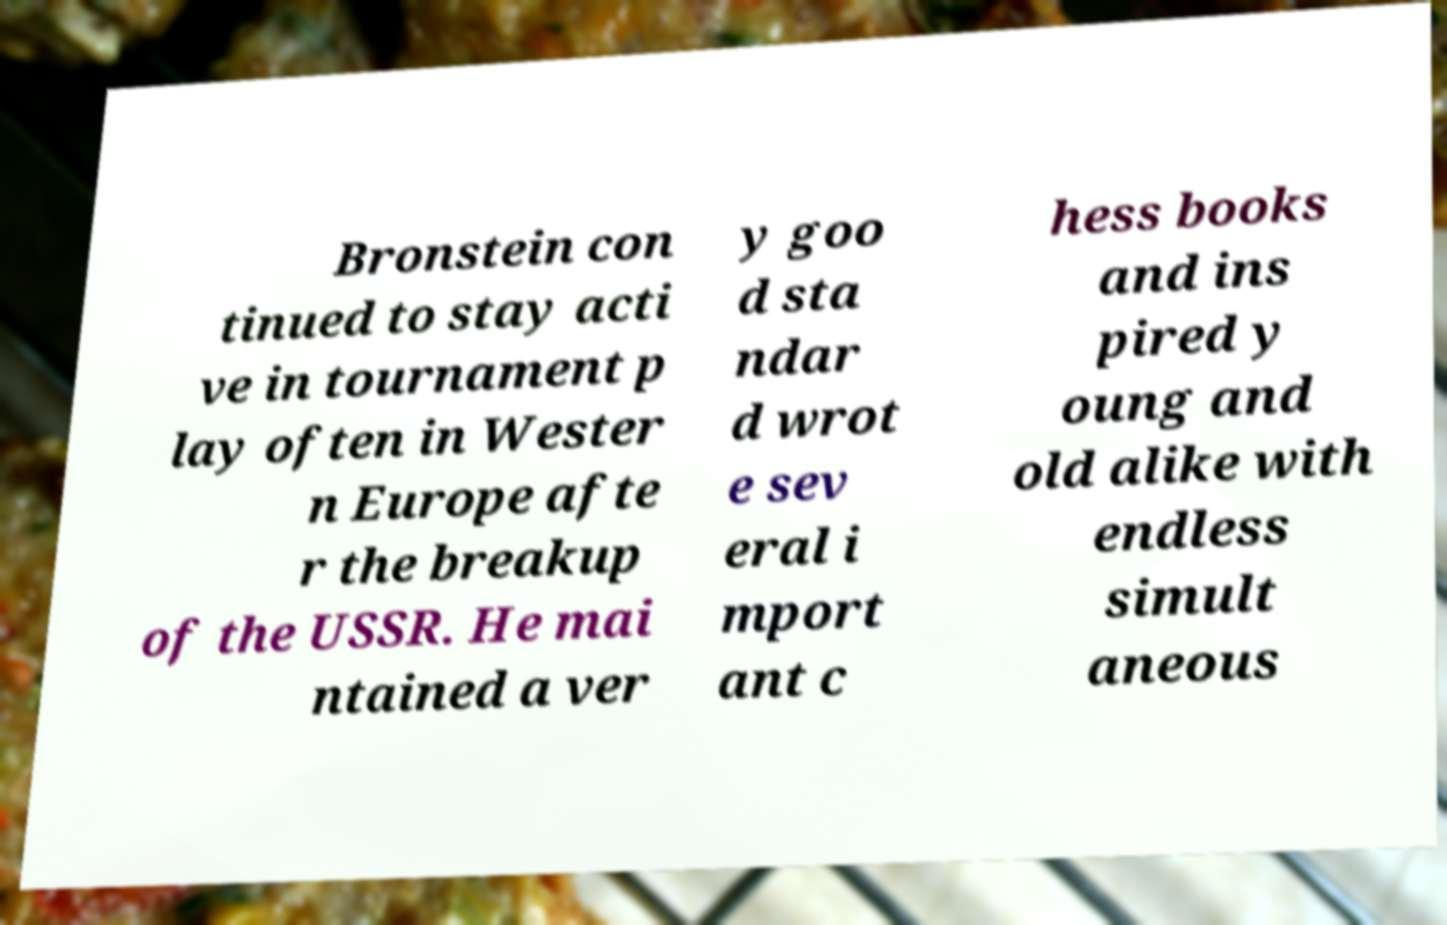For documentation purposes, I need the text within this image transcribed. Could you provide that? Bronstein con tinued to stay acti ve in tournament p lay often in Wester n Europe afte r the breakup of the USSR. He mai ntained a ver y goo d sta ndar d wrot e sev eral i mport ant c hess books and ins pired y oung and old alike with endless simult aneous 